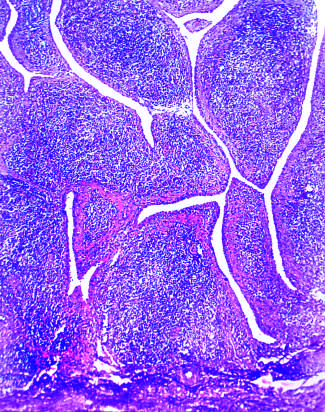does plaque rupture without show marked synovial hypertrophy with formation of villi?
Answer the question using a single word or phrase. No 